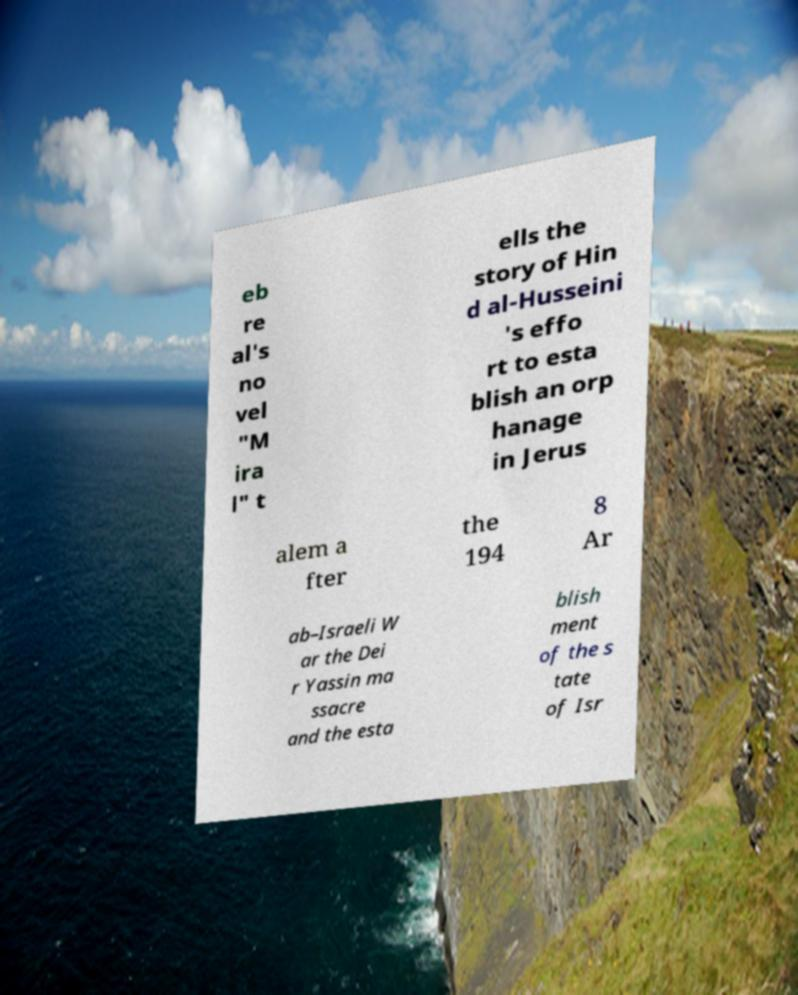Could you assist in decoding the text presented in this image and type it out clearly? eb re al's no vel "M ira l" t ells the story of Hin d al-Husseini 's effo rt to esta blish an orp hanage in Jerus alem a fter the 194 8 Ar ab–Israeli W ar the Dei r Yassin ma ssacre and the esta blish ment of the s tate of Isr 